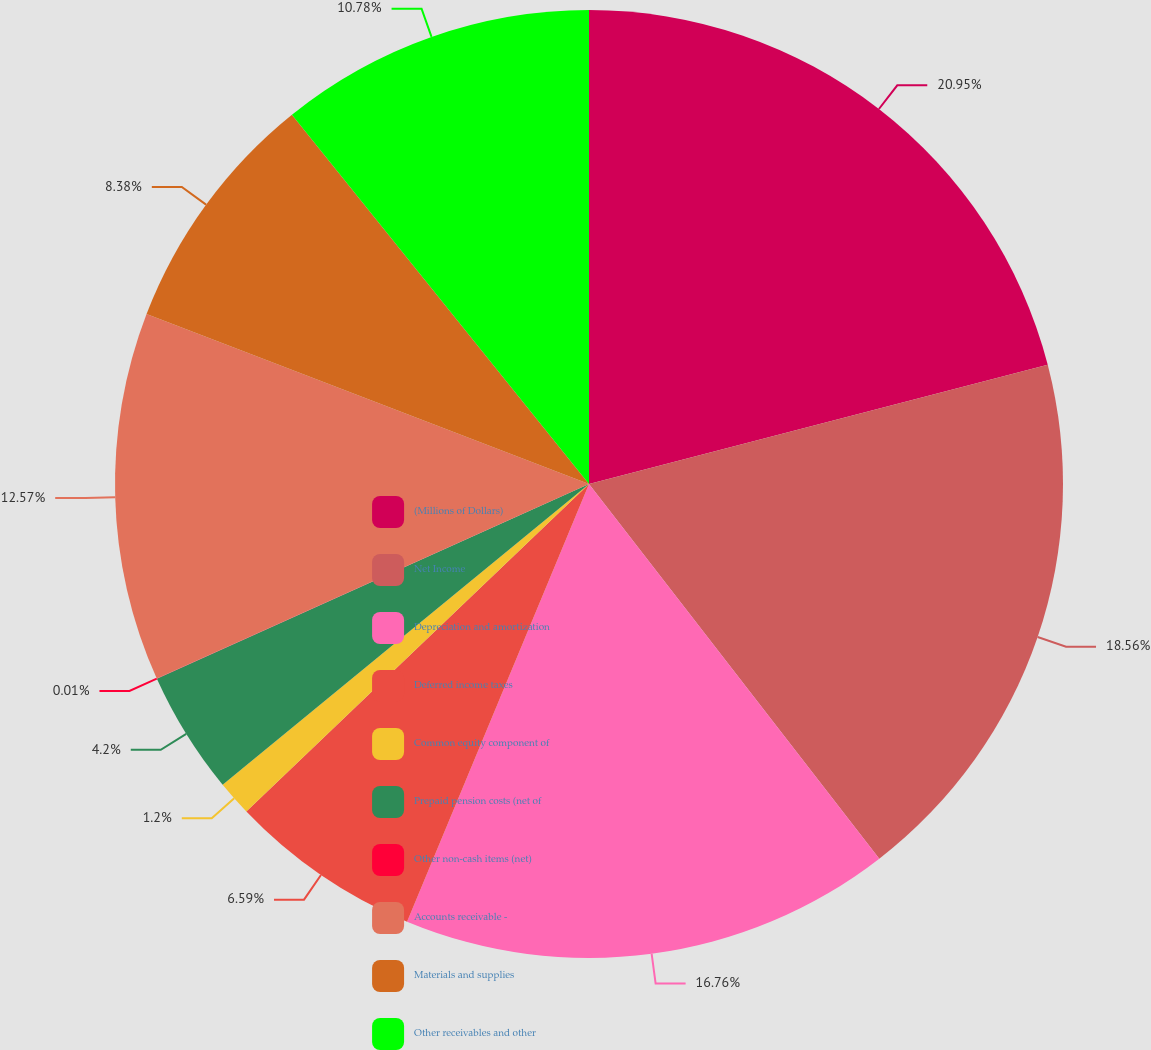<chart> <loc_0><loc_0><loc_500><loc_500><pie_chart><fcel>(Millions of Dollars)<fcel>Net Income<fcel>Depreciation and amortization<fcel>Deferred income taxes<fcel>Common equity component of<fcel>Prepaid pension costs (net of<fcel>Other non-cash items (net)<fcel>Accounts receivable -<fcel>Materials and supplies<fcel>Other receivables and other<nl><fcel>20.95%<fcel>18.56%<fcel>16.76%<fcel>6.59%<fcel>1.2%<fcel>4.2%<fcel>0.01%<fcel>12.57%<fcel>8.38%<fcel>10.78%<nl></chart> 